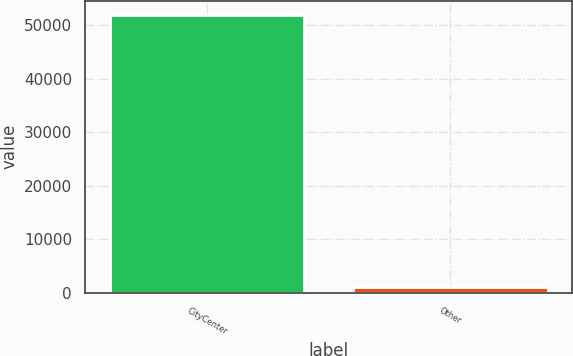Convert chart to OTSL. <chart><loc_0><loc_0><loc_500><loc_500><bar_chart><fcel>CityCenter<fcel>Other<nl><fcel>52010<fcel>1003<nl></chart> 